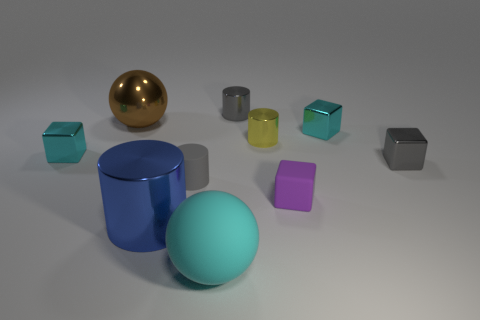How many shiny things are big yellow balls or brown spheres?
Provide a succinct answer. 1. There is a gray cylinder that is behind the metallic block left of the large matte sphere; what is its material?
Your answer should be very brief. Metal. What is the material of the cube that is the same color as the matte cylinder?
Make the answer very short. Metal. The tiny rubber block has what color?
Your answer should be compact. Purple. Is there a big thing in front of the purple rubber object that is right of the cyan matte ball?
Your answer should be compact. Yes. What is the big blue thing made of?
Your answer should be compact. Metal. Do the tiny cube on the left side of the matte block and the cyan block that is right of the yellow cylinder have the same material?
Your response must be concise. Yes. Is there anything else that has the same color as the rubber cylinder?
Offer a very short reply. Yes. There is a tiny rubber object that is the same shape as the yellow metal object; what is its color?
Offer a terse response. Gray. There is a metallic object that is both to the right of the small purple rubber object and on the left side of the gray cube; how big is it?
Keep it short and to the point. Small. 